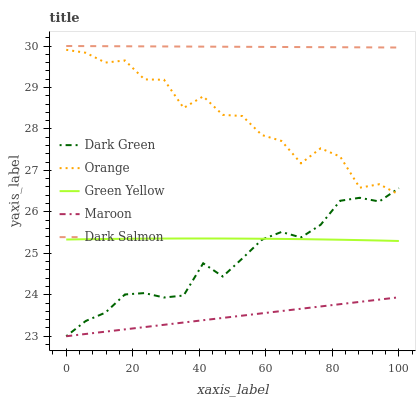Does Maroon have the minimum area under the curve?
Answer yes or no. Yes. Does Dark Salmon have the maximum area under the curve?
Answer yes or no. Yes. Does Green Yellow have the minimum area under the curve?
Answer yes or no. No. Does Green Yellow have the maximum area under the curve?
Answer yes or no. No. Is Maroon the smoothest?
Answer yes or no. Yes. Is Orange the roughest?
Answer yes or no. Yes. Is Green Yellow the smoothest?
Answer yes or no. No. Is Green Yellow the roughest?
Answer yes or no. No. Does Maroon have the lowest value?
Answer yes or no. Yes. Does Green Yellow have the lowest value?
Answer yes or no. No. Does Dark Salmon have the highest value?
Answer yes or no. Yes. Does Green Yellow have the highest value?
Answer yes or no. No. Is Maroon less than Orange?
Answer yes or no. Yes. Is Orange greater than Maroon?
Answer yes or no. Yes. Does Green Yellow intersect Dark Green?
Answer yes or no. Yes. Is Green Yellow less than Dark Green?
Answer yes or no. No. Is Green Yellow greater than Dark Green?
Answer yes or no. No. Does Maroon intersect Orange?
Answer yes or no. No. 